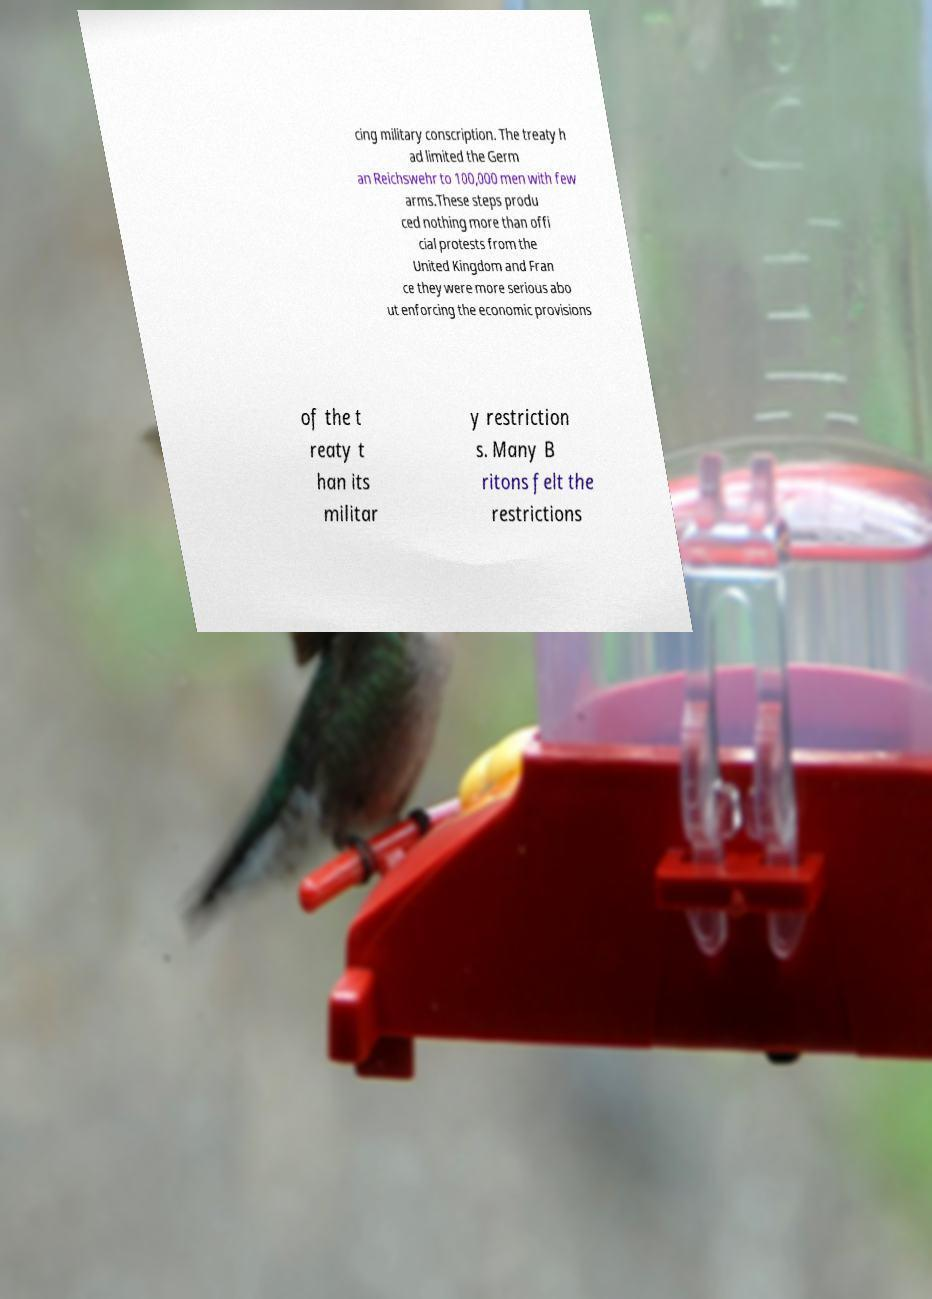Could you extract and type out the text from this image? cing military conscription. The treaty h ad limited the Germ an Reichswehr to 100,000 men with few arms.These steps produ ced nothing more than offi cial protests from the United Kingdom and Fran ce they were more serious abo ut enforcing the economic provisions of the t reaty t han its militar y restriction s. Many B ritons felt the restrictions 